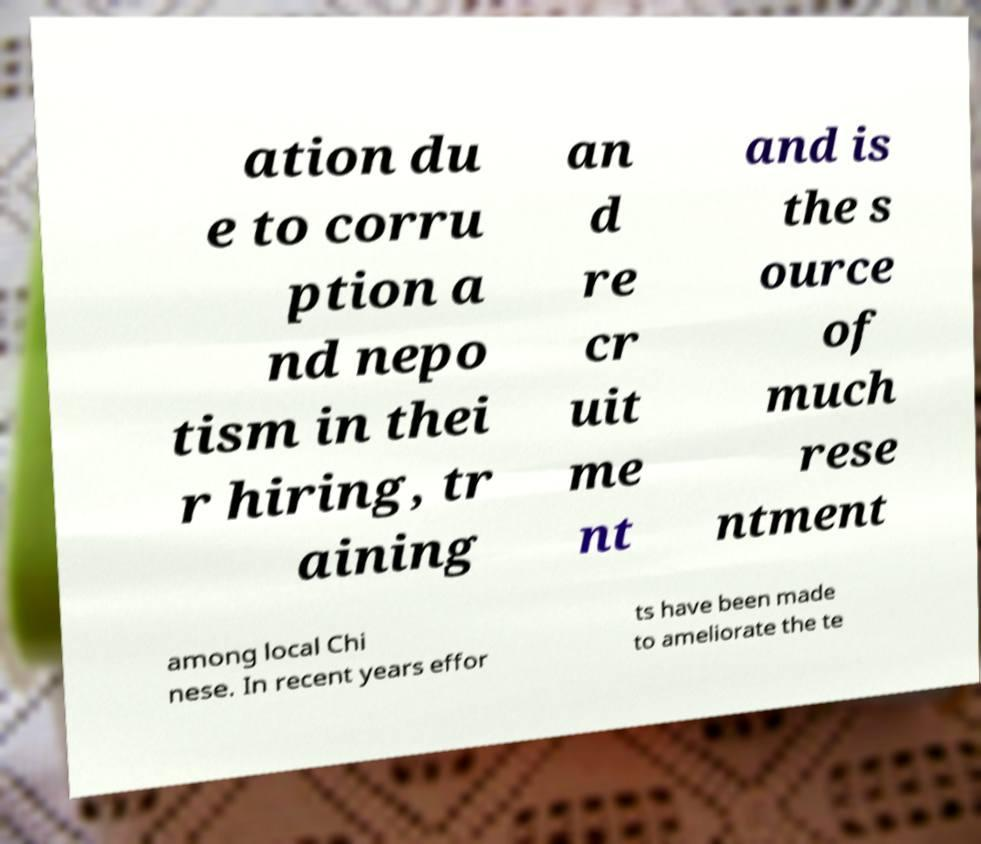For documentation purposes, I need the text within this image transcribed. Could you provide that? ation du e to corru ption a nd nepo tism in thei r hiring, tr aining an d re cr uit me nt and is the s ource of much rese ntment among local Chi nese. In recent years effor ts have been made to ameliorate the te 